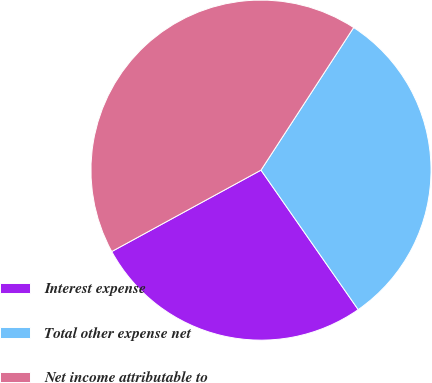Convert chart to OTSL. <chart><loc_0><loc_0><loc_500><loc_500><pie_chart><fcel>Interest expense<fcel>Total other expense net<fcel>Net income attributable to<nl><fcel>26.74%<fcel>31.14%<fcel>42.12%<nl></chart> 